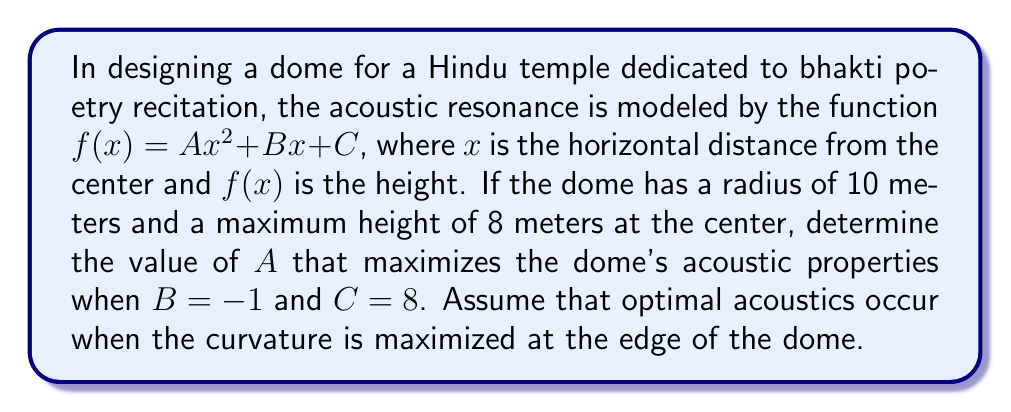Give your solution to this math problem. To solve this problem, we'll follow these steps:

1) The curvature of a function is given by the absolute value of its second derivative. For a quadratic function, this is constant and equal to $2|A|$.

2) We need to maximize $2|A|$, which is equivalent to maximizing $|A|$.

3) We have two constraints:
   a) $f(0) = C = 8$ (maximum height at the center)
   b) $f(10) = 0$ (height at the edge of the dome)

4) Using constraint (b):
   $0 = A(10)^2 + B(10) + C$
   $0 = 100A - 10 + 8$
   $100A = 2$
   $A = \frac{1}{50} = 0.02$

5) We don't need to check constraint (a) as it's already satisfied by the given $C$ value.

6) The positive value of $A$ we found maximizes the curvature and thus the acoustic properties.

Therefore, the optimal value of $A$ is $0.02$.
Answer: $A = 0.02$ 